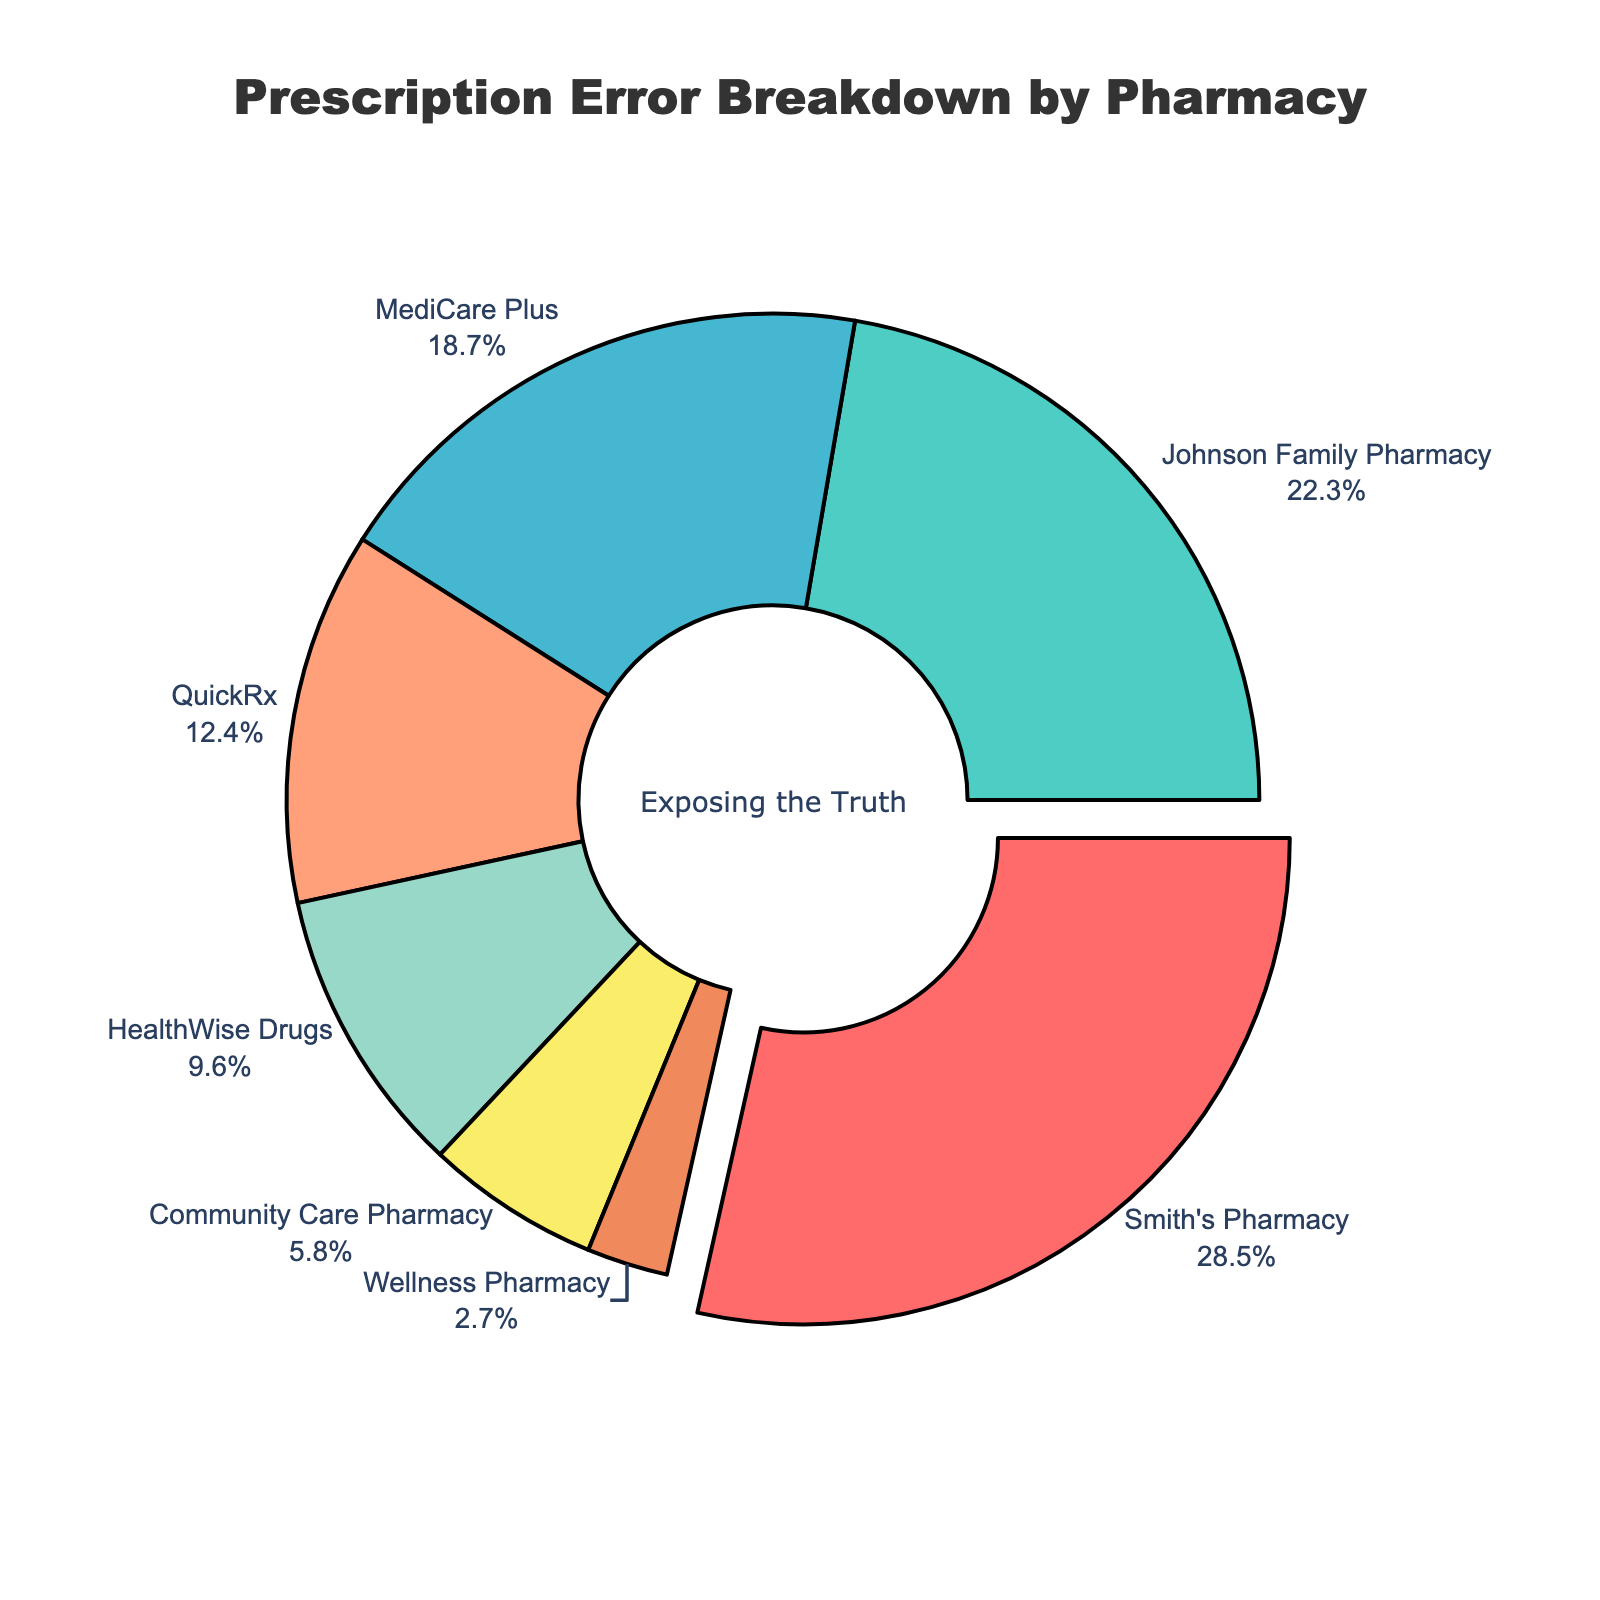Which pharmacy reports the highest percentage of prescription errors? By visually observing the pie chart, the largest slice will indicate the highest percentage. The slice with the highest percentage will typically be pulled out for emphasis. Smith's Pharmacy shows the largest segment on this chart.
Answer: Smith's Pharmacy What is the combined percentage of prescription errors reported by Johnson Family Pharmacy and MediCare Plus? Add the percentages reported by Johnson Family Pharmacy and MediCare Plus from the figure. Johnson Family Pharmacy is 22.3% and MediCare Plus is 18.7%. Summing these values, 22.3 + 18.7 = 41.0%.
Answer: 41.0% Which pharmacy reports fewer errors, Community Care Pharmacy or Wellness Pharmacy? Compare the sizes of the slices representing Community Care Pharmacy and Wellness Pharmacy. Community Care Pharmacy shows 5.8% while Wellness Pharmacy shows 2.7%. Since 2.7% is less than 5.8%, Wellness Pharmacy reports fewer errors.
Answer: Wellness Pharmacy What is the difference in error rates between Smith's Pharmacy and QuickRx? Subtract the percentage of QuickRx from Smith’s Pharmacy. Smith’s Pharmacy has 28.5% and QuickRx has 12.4%. The difference is 28.5 - 12.4 = 16.1%.
Answer: 16.1% What is the total percentage of prescription errors accounted for by Smith's Pharmacy, Johnson Family Pharmacy, and QuickRx? Add the percentages of these three pharmacies. Smith’s Pharmacy is 28.5%, Johnson Family Pharmacy is 22.3%, and QuickRx is 12.4%. So, 28.5 + 22.3 + 12.4 = 63.2%.
Answer: 63.2% What percentage of prescription errors is reported by pharmacies other than the top three? First, identify the top three pharmacies by percentage (Smith’s Pharmacy, Johnson Family Pharmacy, and MediCare Plus). Then sum their percentages (28.5% + 22.3% + 18.7% = 69.5%). Subtract this from 100% to get the percentage for other pharmacies (100 - 69.5 = 30.5%).
Answer: 30.5% Which pharmacy's percentage of prescription errors falls closest to 10%? Locate the slice that is visually closest to the 10% mark. HealthWise Drugs reports 9.6%, which is closest to 10%.
Answer: HealthWise Drugs How much larger is the error percentage of Smith's Pharmacy compared to HealthWise Drugs? Subtract HealthWise Drugs' percentage from Smith's Pharmacy's. Smith's Pharmacy has 28.5% and HealthWise Drugs has 9.6%. The difference is 28.5 - 9.6 = 18.9%.
Answer: 18.9% Which pharmacy has the smallest proportion of prescription errors? Identify which slice of the pie chart is the smallest. The smallest slice is represented by Wellness Pharmacy at 2.7%.
Answer: Wellness Pharmacy 